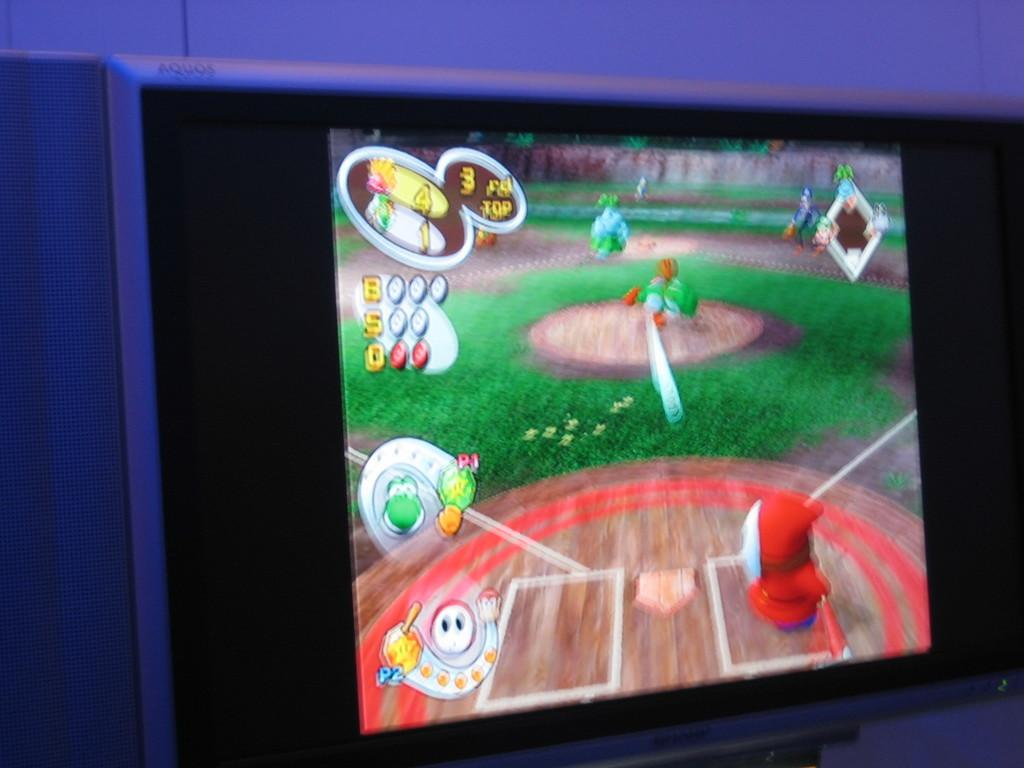<image>
Describe the image concisely. A monitor shows a blurred but colourful image of a video game and the player is 3rd top. 